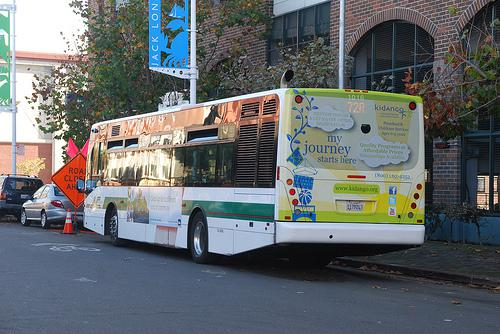Question: where are bricks?
Choices:
A. On the walkway.
B. On a building.
C. In the truck.
D. On the ground.
Answer with the letter. Answer: B Question: what is round?
Choices:
A. Plates.
B. Map.
C. Tires.
D. Ball.
Answer with the letter. Answer: C Question: where was the photo taken?
Choices:
A. Airport.
B. A city street.
C. Train station.
D. Bus stop.
Answer with the letter. Answer: B Question: what is gray?
Choices:
A. Road.
B. The mood.
C. The sidewalk.
D. The store.
Answer with the letter. Answer: A Question: when was the picture taken?
Choices:
A. At dawn.
B. At dusk.
C. Daytime.
D. In the morning.
Answer with the letter. Answer: C Question: where is a bus?
Choices:
A. Near the sidewalk.
B. Near the trees.
C. On the road.
D. By the man.
Answer with the letter. Answer: C 